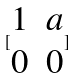Convert formula to latex. <formula><loc_0><loc_0><loc_500><loc_500>[ \begin{matrix} 1 & a \\ 0 & 0 \end{matrix} ]</formula> 